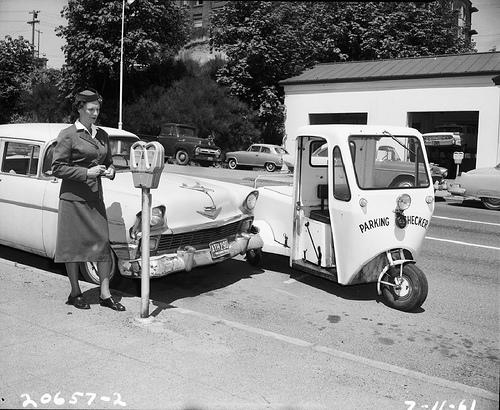Question: what does the meter maid car say?
Choices:
A. Police.
B. Emergency.
C. Parking checker.
D. Ambulance.
Answer with the letter. Answer: C Question: what date is on the bottom of the photo?
Choices:
A. June 21.
B. 26 May 2015.
C. January 1, 2001.
D. 7-11-61.
Answer with the letter. Answer: D Question: where is this shot?
Choices:
A. Sidewalk.
B. Playground.
C. Driveway.
D. Schoolyard.
Answer with the letter. Answer: A Question: how many vehicles are shown?
Choices:
A. 8.
B. 7.
C. 6.
D. 5.
Answer with the letter. Answer: B 